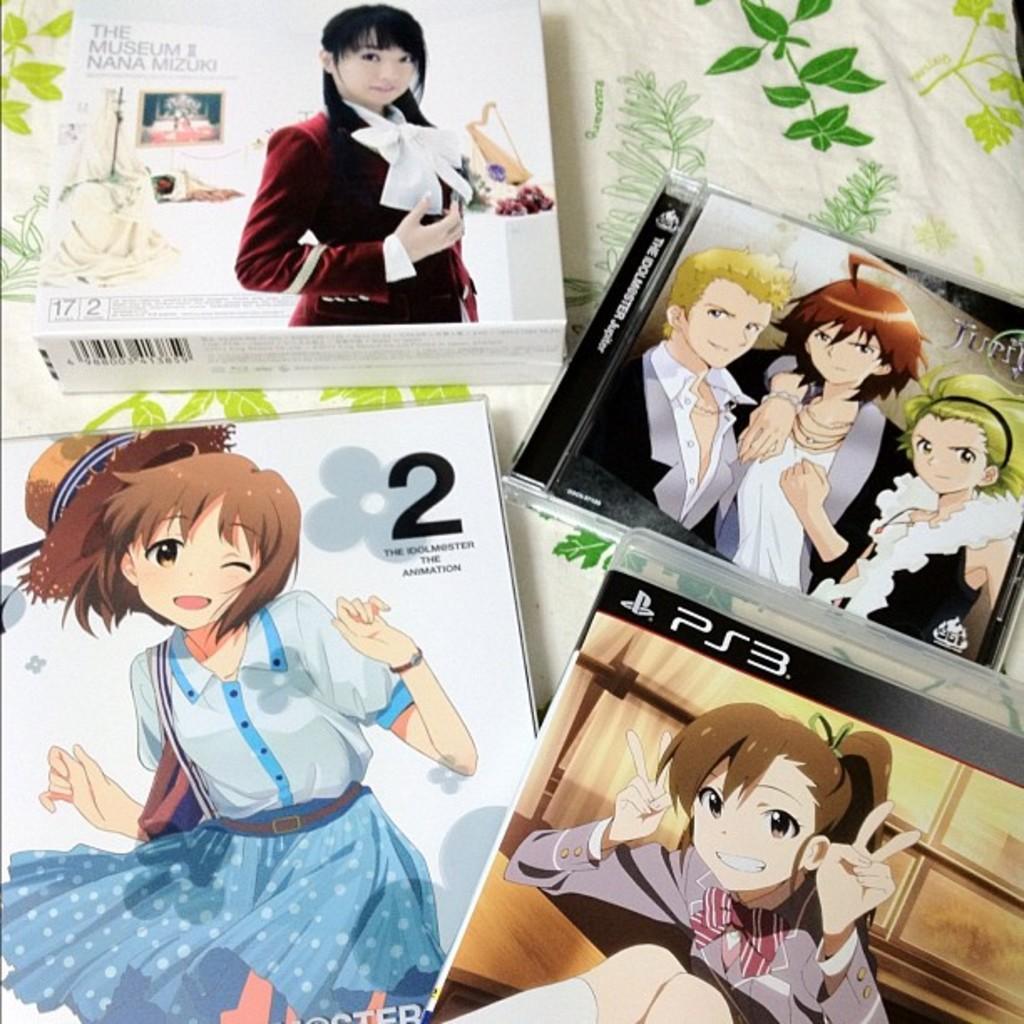Could you give a brief overview of what you see in this image? In this image, we can see some boxes and there are some cartoons printed on the boxes. 